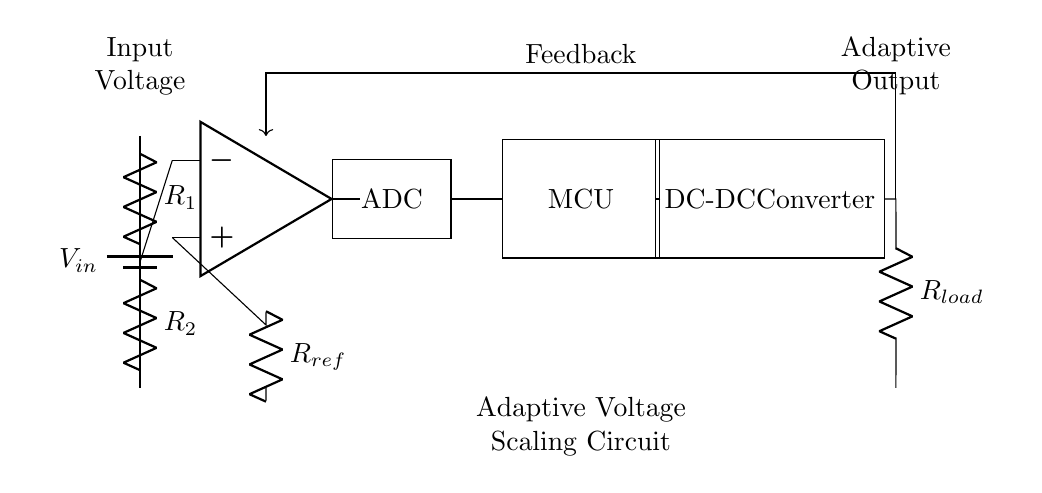What is the input voltage of the circuit? The input voltage is represented by V_in, which is indicated by the battery symbol at the beginning of the circuit.
Answer: V_in What type of component is used for voltage division? The voltage divider is created using two resistors in series, labeled as R_1 and R_2, which are both connected vertically in the circuit diagram.
Answer: Resistors What is the purpose of the op-amp in this circuit? The operational amplifier acts as a comparator, receiving the voltage from the voltage divider at its negative input and a reference voltage at its positive input, producing an output based on the comparison.
Answer: Comparator Which component converts the DC voltage into a different DC voltage level? The DC-DC converter is responsible for adjusting the output voltage based on the feedback mechanism from the load, ensuring energy efficiency.
Answer: DC-DC Converter How does feedback affect the circuit's operation? Feedback is provided from the load back to the op-amp, allowing the circuit to adjust its output voltage dynamically to maintain energy efficiency, responding to changes in load conditions.
Answer: It adjusts output voltage What is the role of the ADC in the circuit? The ADC (Analog-to-Digital Converter) converts the analog voltage output from the op-amp into a digital signal for processing by the microcontroller, which is essential for adaptive voltage scaling.
Answer: Conversion of analog voltage Which resistor serves as the reference for the comparator? The resistor labeled R_ref provides a stable reference voltage to the positive input of the operational amplifier for comparison with the output from the voltage divider.
Answer: R_ref 